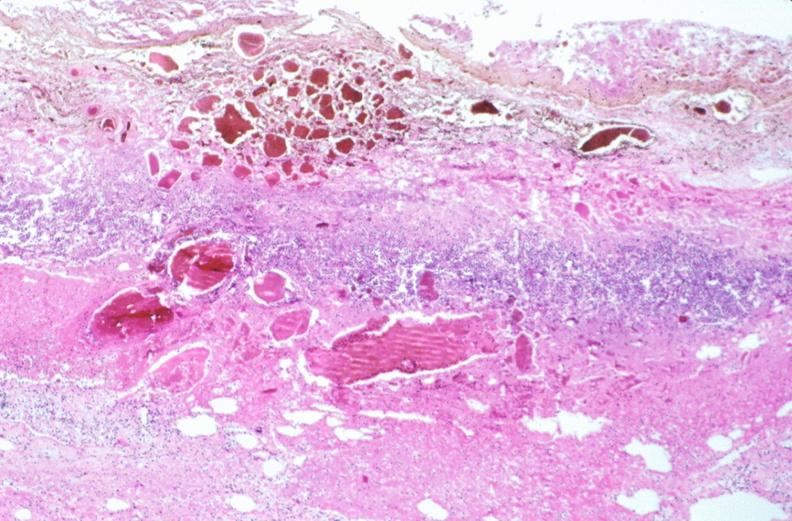s this section present?
Answer the question using a single word or phrase. No 